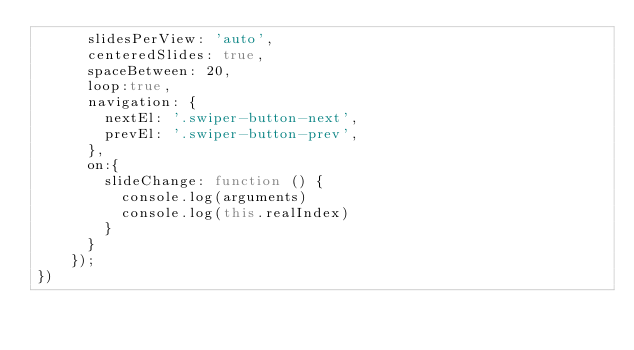<code> <loc_0><loc_0><loc_500><loc_500><_JavaScript_>      slidesPerView: 'auto',
      centeredSlides: true,
      spaceBetween: 20,
      loop:true,
      navigation: {
        nextEl: '.swiper-button-next',
        prevEl: '.swiper-button-prev',
      },
      on:{
      	slideChange: function () {
      		console.log(arguments)
      		console.log(this.realIndex)
      	}
      }
    });
})</code> 